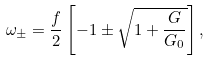<formula> <loc_0><loc_0><loc_500><loc_500>\omega _ { \pm } = \frac { f } { 2 } \left [ - 1 \pm \sqrt { 1 + \frac { G } { G _ { 0 } } } \right ] ,</formula> 